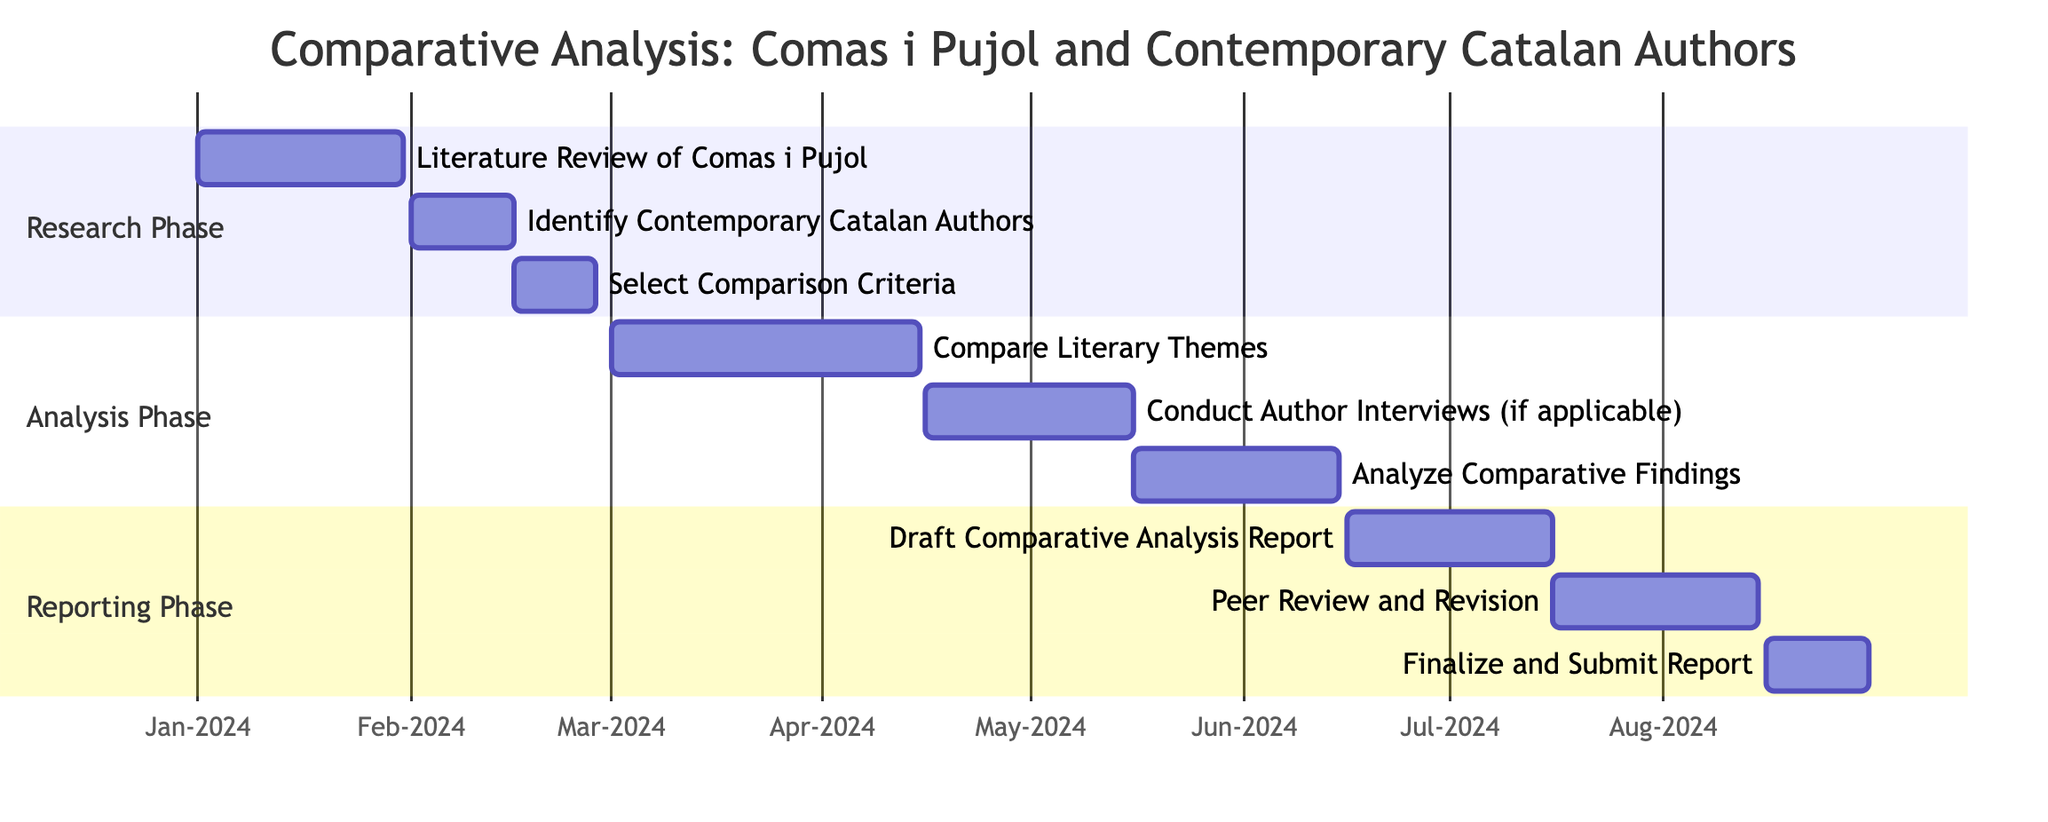What is the duration of the Literature Review of Comas i Pujol? The duration is stated in the task details, which specifies that the Literature Review of Comas i Pujol lasts for 30 days, starting from January 1, 2024.
Answer: 30 days How many total tasks are there in the project? By counting each task listed in the Gantt chart, we find there are 9 tasks represented in the project timeline.
Answer: 9 What is the start date of the Analyze Comparative Findings task? The start date for the Analyze Comparative Findings task is indicated as May 16, 2024, according to the task details in the diagram.
Answer: May 16, 2024 Which task follows the selection of comparison criteria in the timeline? The task that follows the selection of comparison criteria is the Compare Literary Themes, starting from March 1, 2024.
Answer: Compare Literary Themes How many days are allocated for the Peer Review and Revision? The time allocated for Peer Review and Revision is indicated as 30 days, starting from July 16, 2024, to August 15, 2024.
Answer: 30 days What is the last task to be completed in the project? The last task to be completed is the Finalize and Submit Report, which is slated to end on August 31, 2024.
Answer: Finalize and Submit Report What is the total duration of the Analysis Phase? The Analysis Phase consists of three tasks: Compare Literary Themes (45 days), Conduct Author Interviews (30 days), and Analyze Comparative Findings (30 days). Adding these durations together gives a total of 105 days for the Analysis Phase.
Answer: 105 days Which task has the longest duration? By comparing the durations of all tasks, it is clear that the Compare Literary Themes task has the longest duration at 45 days.
Answer: Compare Literary Themes What is the gap between the completion of the Compare Literary Themes and the start of Conduct Author Interviews? The Compare Literary Themes ends on April 15, and Conduct Author Interviews starts on April 16, indicating there is no gap between these two tasks; they are consecutive.
Answer: No gap 